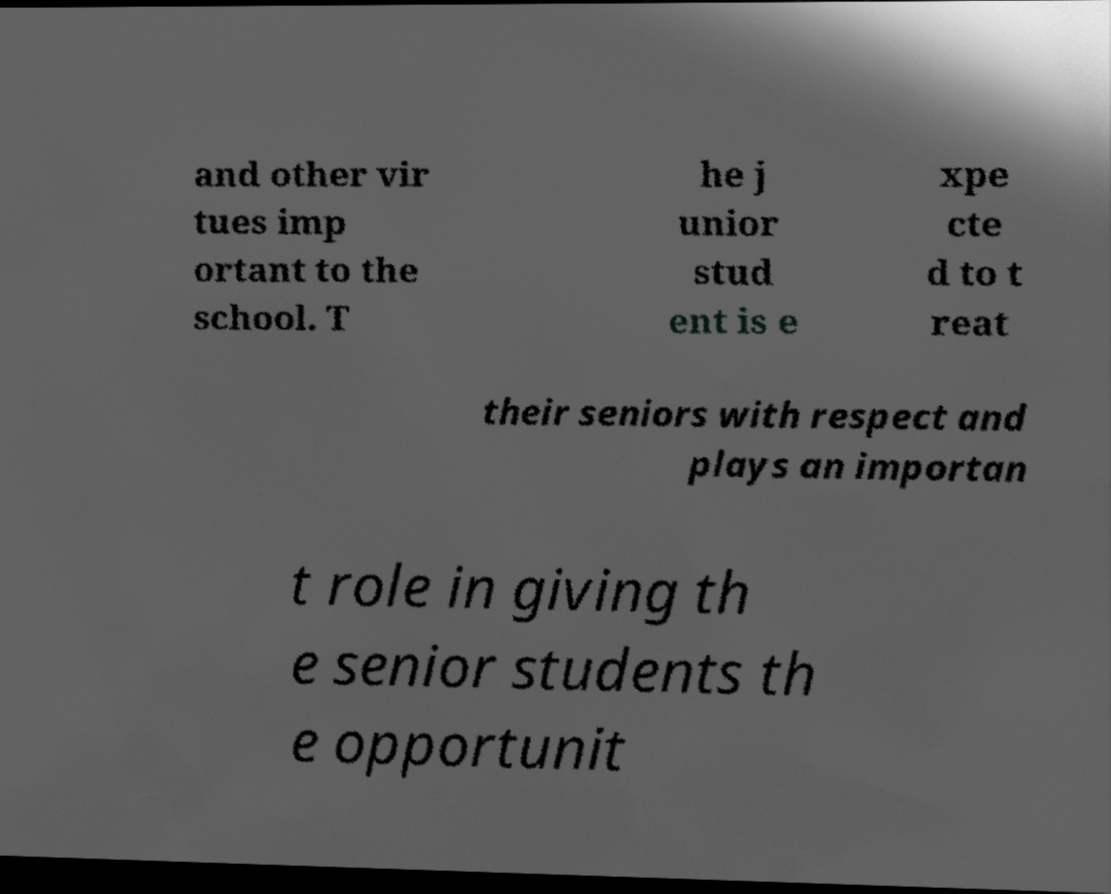Please read and relay the text visible in this image. What does it say? and other vir tues imp ortant to the school. T he j unior stud ent is e xpe cte d to t reat their seniors with respect and plays an importan t role in giving th e senior students th e opportunit 